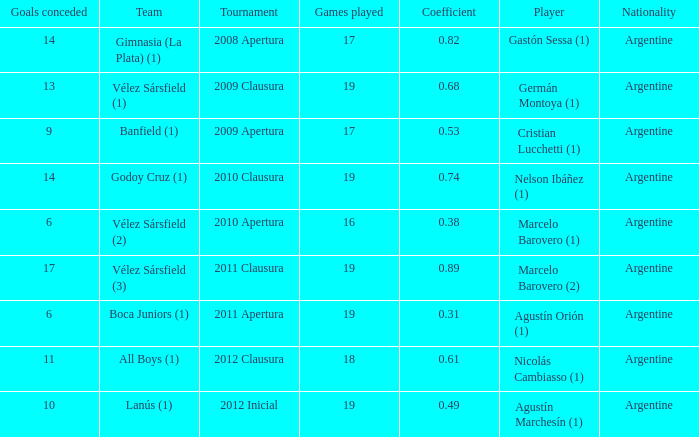 the 2010 clausura tournament? 0.74. 